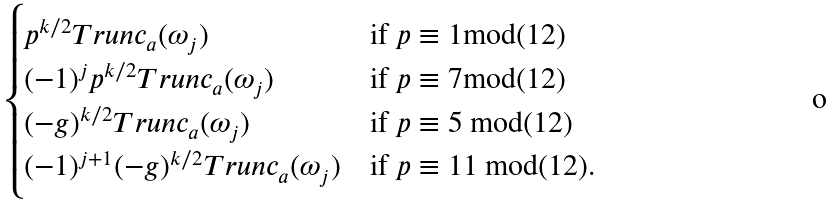<formula> <loc_0><loc_0><loc_500><loc_500>\begin{cases} p ^ { k / 2 } T r u n c _ { a } ( \omega _ { j } ) & \text {if } p \equiv 1 \text {mod(12)} \\ ( - 1 ) ^ { j } p ^ { k / 2 } T r u n c _ { a } ( \omega _ { j } ) & \text {if } p \equiv 7 \text {mod(12)} \\ ( - g ) ^ { k / 2 } T r u n c _ { a } ( \omega _ { j } ) & \text {if } p \equiv 5 \text { mod(12)} \\ ( - 1 ) ^ { j + 1 } ( - g ) ^ { k / 2 } T r u n c _ { a } ( \omega _ { j } ) & \text {if } p \equiv 1 1 \text { mod(12)} . \end{cases}</formula> 